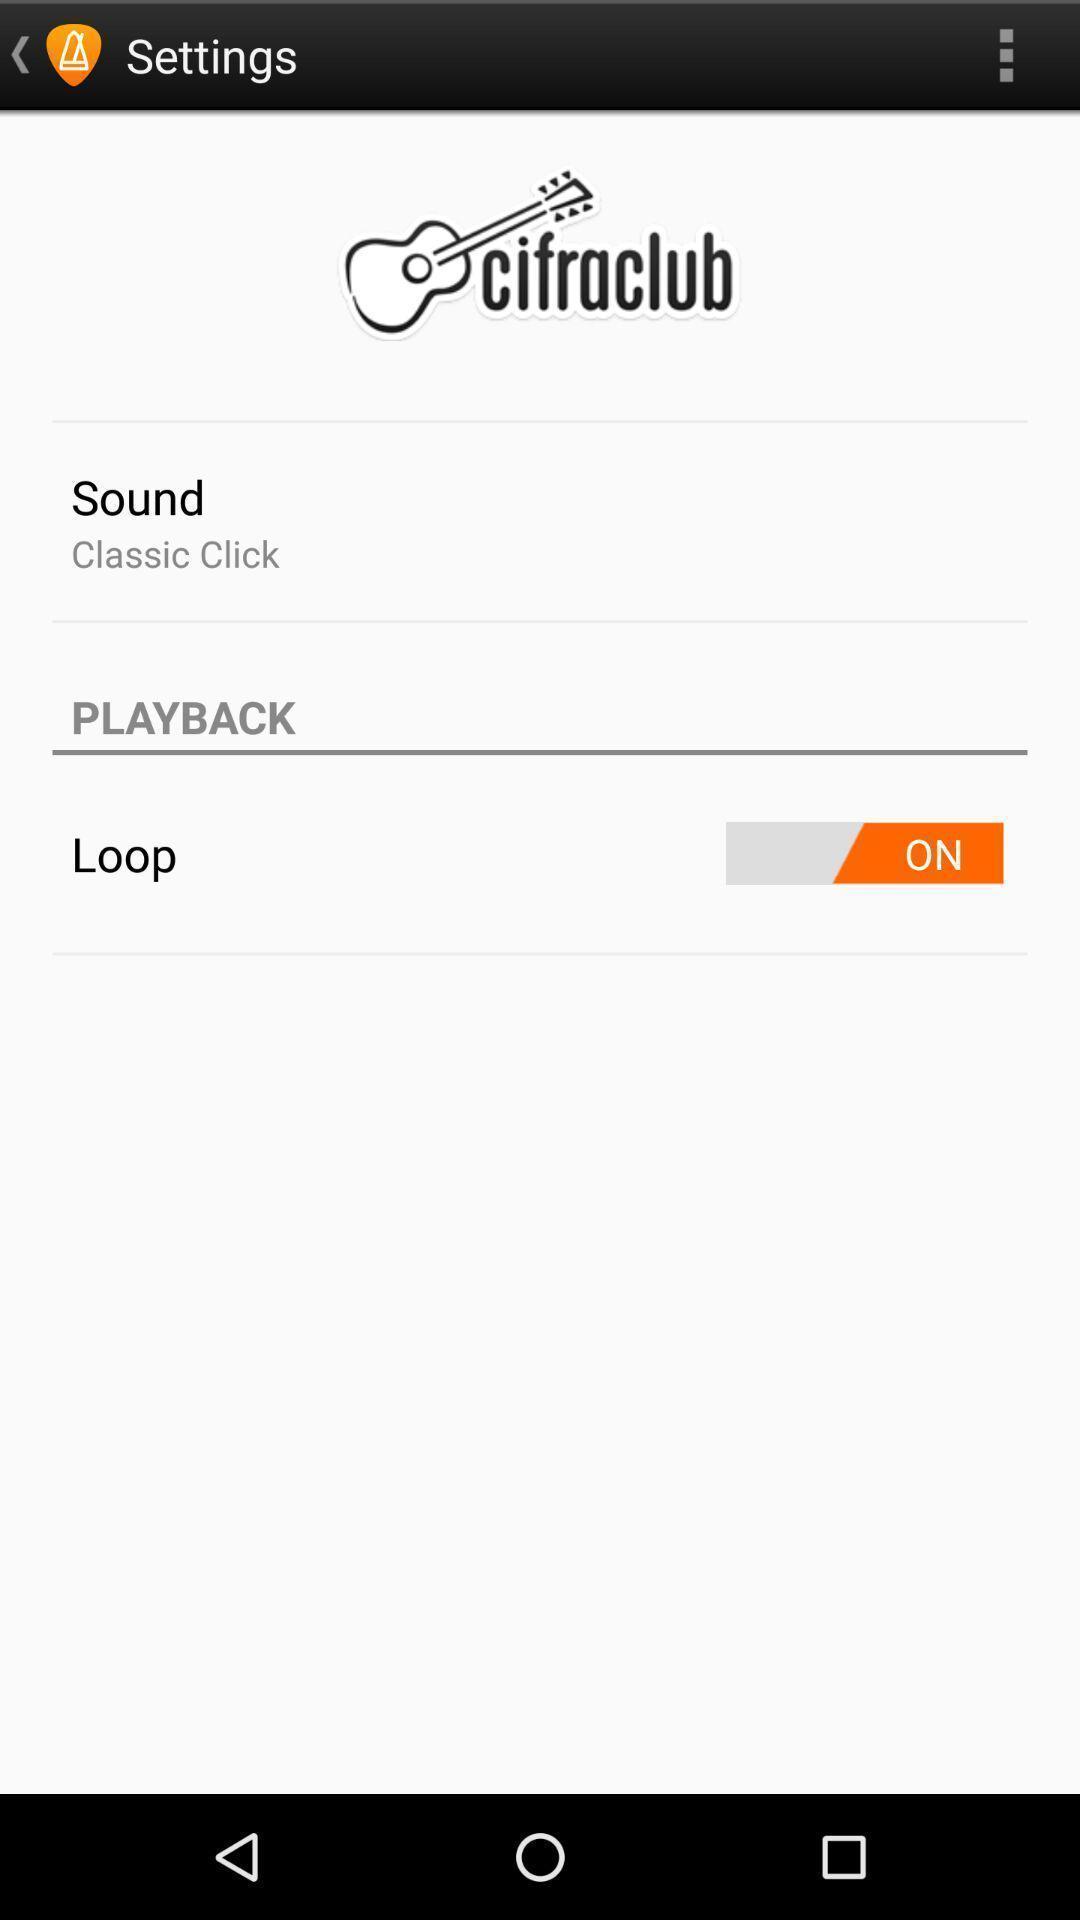Provide a textual representation of this image. Settings page. 